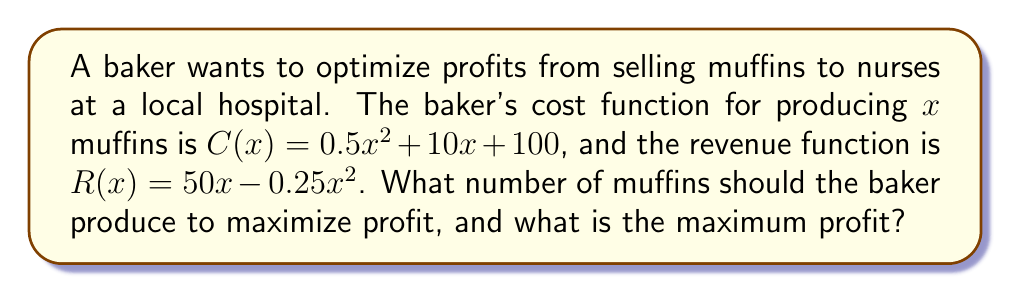Could you help me with this problem? 1. Define the profit function:
   Profit = Revenue - Cost
   $P(x) = R(x) - C(x)$
   $P(x) = (50x - 0.25x^2) - (0.5x^2 + 10x + 100)$
   $P(x) = -0.75x^2 + 40x - 100$

2. To find the maximum profit, we need to find the vertex of this quadratic function.

3. Use the vertex formula: $x = -\frac{b}{2a}$
   $a = -0.75$, $b = 40$
   $x = -\frac{40}{2(-0.75)} = \frac{40}{1.5} = 26.67$

4. Round to the nearest whole number since we can't produce partial muffins:
   $x = 27$ muffins

5. Calculate the maximum profit by plugging x = 27 into the profit function:
   $P(27) = -0.75(27)^2 + 40(27) - 100$
   $= -0.75(729) + 1080 - 100$
   $= -546.75 + 1080 - 100$
   $= 433.25$

Therefore, the baker should produce 27 muffins to maximize profit, and the maximum profit is $433.25.
Answer: 27 muffins; $433.25 